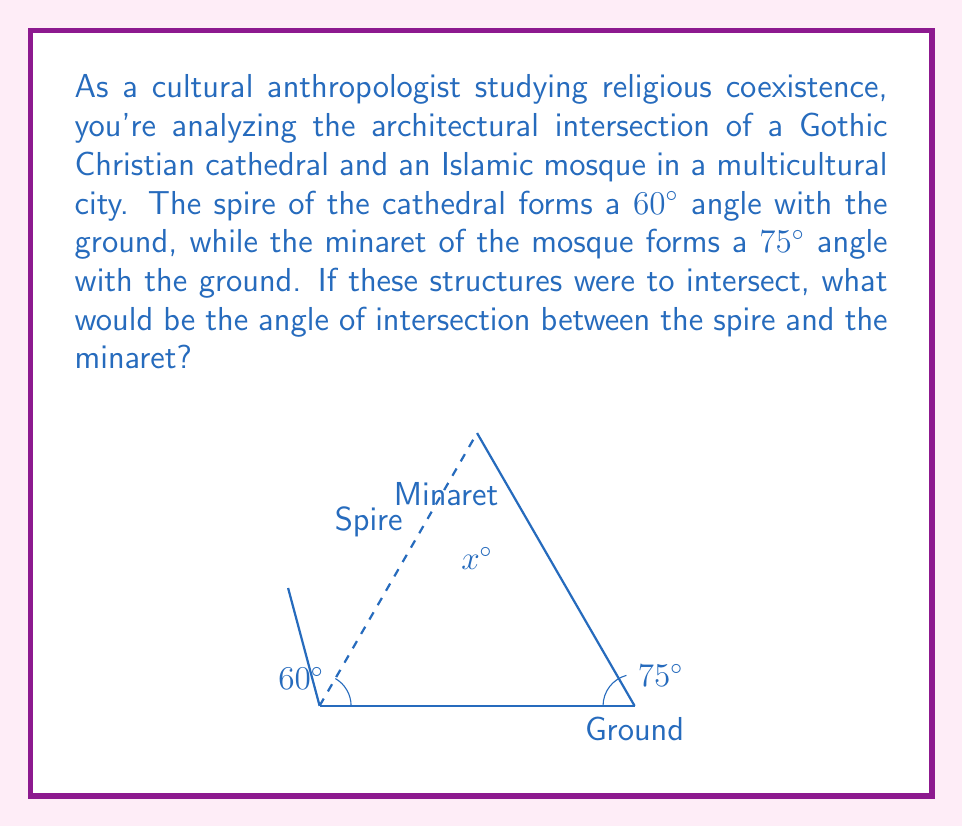Give your solution to this math problem. To solve this problem, we need to use the concept of supplementary angles and the properties of intersecting lines. Let's break it down step by step:

1) First, let's recall that when two straight lines intersect, they form two pairs of supplementary angles. Supplementary angles add up to 180°.

2) In this case, we're interested in the angle of intersection between the spire and the minaret. This angle will be supplementary to the sum of the angles each structure makes with the ground.

3) Let's define the angle of intersection as $x°$. We can set up an equation based on the supplementary angle property:

   $x° + 60° + 75° = 180°$

4) Now we can solve for $x$:

   $x° = 180° - (60° + 75°)$
   $x° = 180° - 135°$
   $x° = 45°$

5) Therefore, the angle of intersection between the spire and the minaret is 45°.

This problem illustrates how geometric principles can be applied to analyze the physical intersection of different architectural styles, which could be a metaphor for the cultural intersections you're studying as an anthropologist.
Answer: The angle of intersection between the cathedral spire and the mosque minaret is $45°$. 